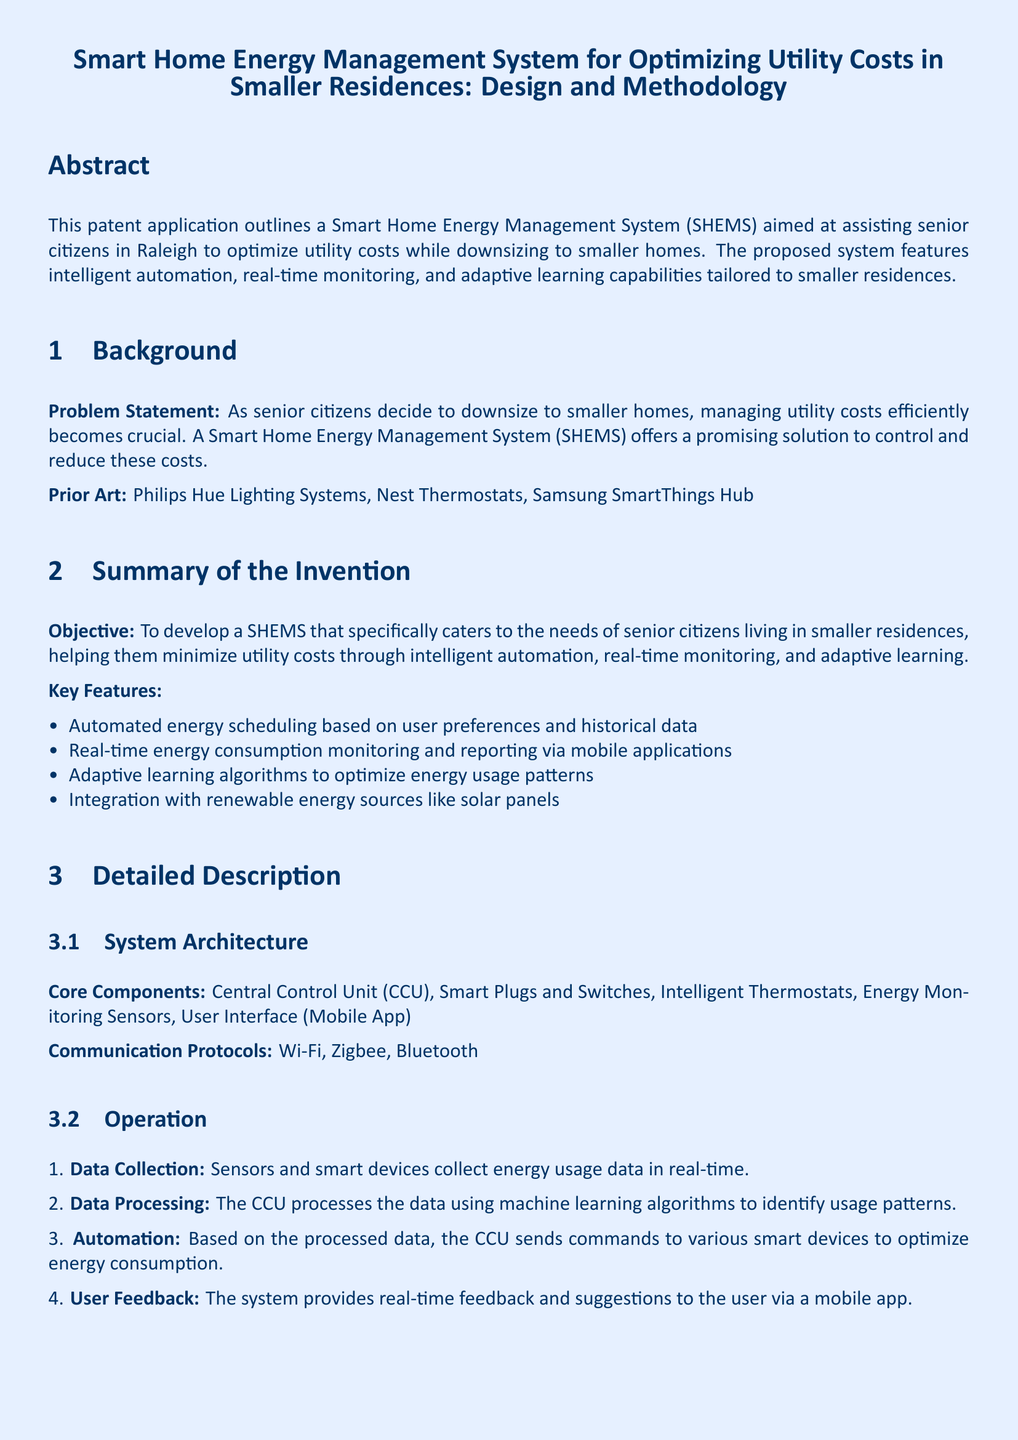What is the main objective of the Smart Home Energy Management System? The main objective as outlined in the document is to develop a SHEMS that specifically caters to the needs of senior citizens living in smaller residences, helping them minimize utility costs through intelligent automation, real-time monitoring, and adaptive learning.
Answer: To develop a SHEMS that specifically caters to the needs of senior citizens living in smaller residences What are the core components of the system? The core components listed in the document include the Central Control Unit, Smart Plugs and Switches, Intelligent Thermostats, Energy Monitoring Sensors, and User Interface (Mobile App).
Answer: Central Control Unit, Smart Plugs and Switches, Intelligent Thermostats, Energy Monitoring Sensors, User Interface How much can a senior citizen potentially reduce their electricity costs by using SHEMS? The implementation example states that a senior citizen in Raleigh can reduce electricity costs by 20 percent by using SHEMS.
Answer: 20% What technologies are used for communication in the system? The communication protocols mentioned in the document include Wi-Fi, Zigbee, and Bluetooth.
Answer: Wi-Fi, Zigbee, Bluetooth What function does the CCU serve in the system? The CCU is responsible for processing the collected data using machine learning algorithms to identify usage patterns, as described in the operation section.
Answer: Data processing What features help optimize energy usage patterns? The key feature mentioned in the document that helps optimize energy usage patterns is the adaptive learning algorithms.
Answer: Adaptive learning algorithms Which renewable energy source is integrated into the system? The document specifies that solar panels are integrated with the SHEMS to provide renewable energy solutions.
Answer: Solar panels What is one of the potential advantages of using this system? One of the potential advantages outlined in the document is cost efficiency, which leads to significant reduction in utility bills.
Answer: Cost Efficiency 